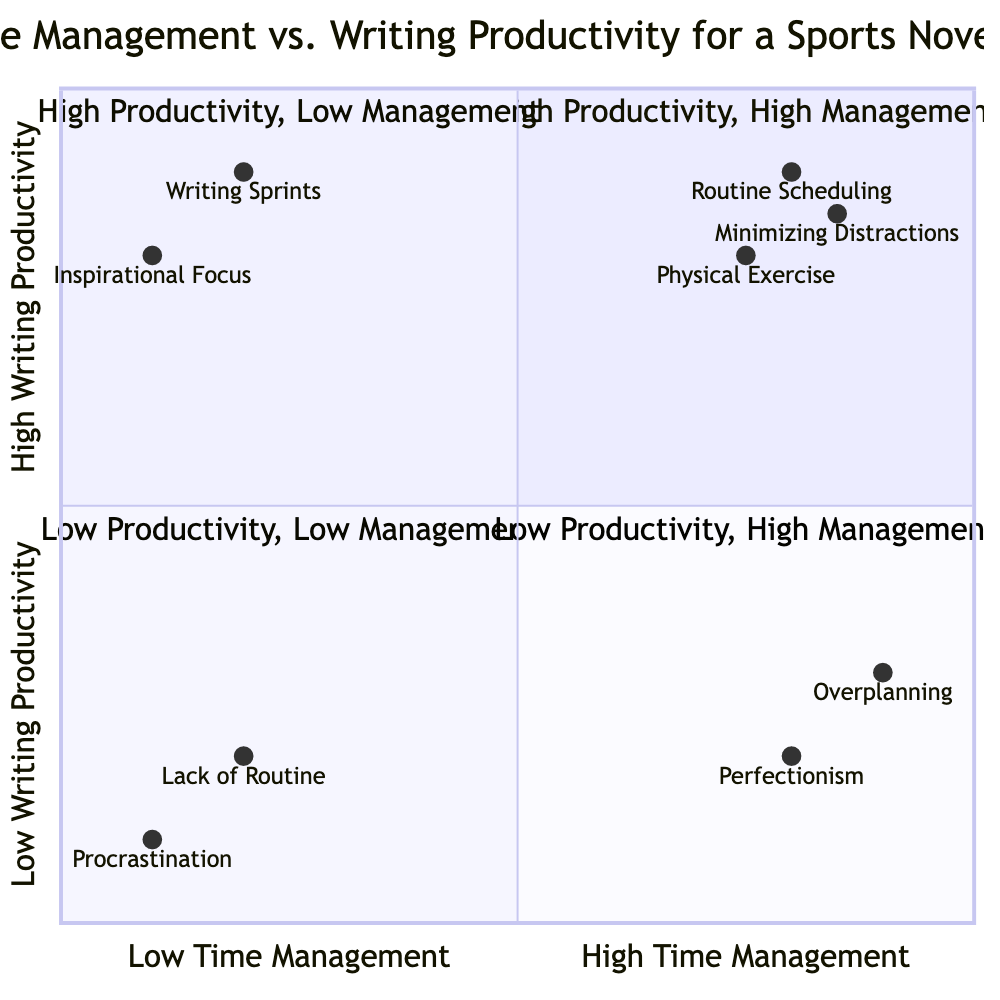What activities are in the High Time Management - High Writing Productivity quadrant? The High Time Management - High Writing Productivity quadrant includes "Routine Scheduling," "Minimizing Distractions," and "Physical Exercise" as activities aimed at boosting both time management and writing productivity.
Answer: Routine Scheduling, Minimizing Distractions, Physical Exercise How many activities are in the Low Time Management - Low Writing Productivity quadrant? The Low Time Management - Low Writing Productivity quadrant contains two activities: "Procrastination" and "Lack of Routine." Thus, there are a total of two activities in this quadrant.
Answer: 2 Which activity is in the High Time Management - Low Writing Productivity quadrant? The High Time Management - Low Writing Productivity quadrant includes "Overplanning" and "Perfectionism." Therefore, both activities demonstrate high time management but low writing productivity.
Answer: Overplanning, Perfectionism What is the most productive activity that lacks time management? The Low Time Management - High Writing Productivity quadrant features "Writing Sprints" and "Inspirational Focus." Among these, "Writing Sprints" is positioned higher in productivity, making it the most productive activity without structured time management.
Answer: Writing Sprints Which activity ranks highest in writing productivity? In the High Time Management - High Writing Productivity quadrant, "Minimizing Distractions" has the highest writing productivity ranking at 0.85, indicating its effectiveness in enhancing output.
Answer: Minimizing Distractions What do both procrastination and lack of routine have in common? Both "Procrastination" and "Lack of Routine" appear in the Low Time Management - Low Writing Productivity quadrant, indicating that both lead to low output in writing and poor time management, reflecting a lack of structure.
Answer: Low Time Management, Low Writing Productivity Which quadrant contains activities that are primarily focused on high writing productivity? The High Writing Productivity quadrants are represented by both the High Time Management - High Writing Productivity and Low Time Management - High Writing Productivity quadrants. Thus, activities that enhance writing productivity can be found in both quadrants.
Answer: High Time Management - High Writing Productivity, Low Time Management - High Writing Productivity What is the relationship between Overplanning and High Time Management? "Overplanning" is categorized in the High Time Management - Low Writing Productivity quadrant. This illustrates that while it involves significant management of time, it does not correspond to high productivity in writing.
Answer: High Time Management, Low Writing Productivity 